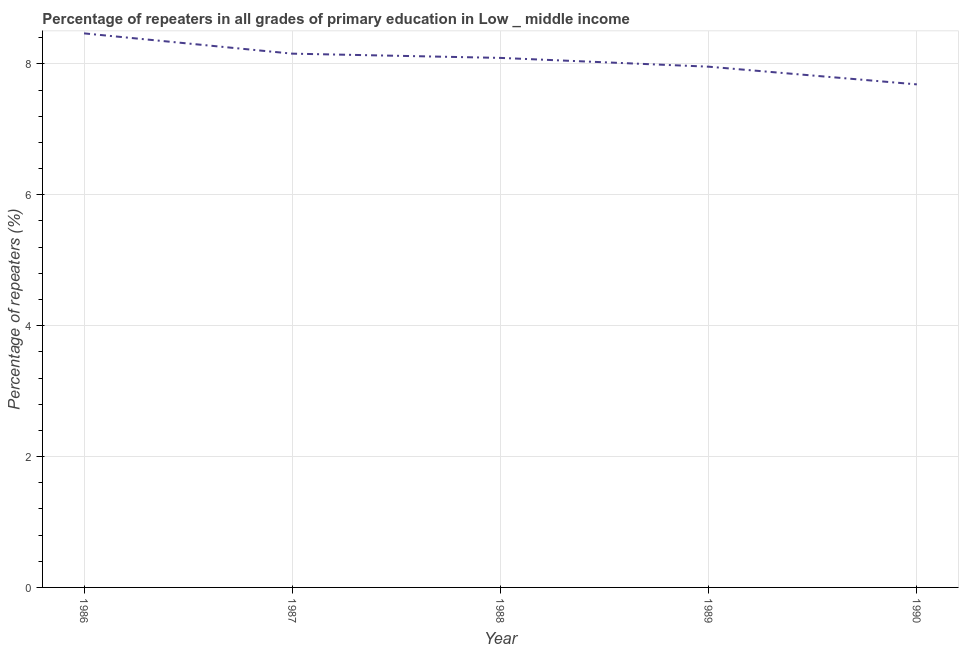What is the percentage of repeaters in primary education in 1988?
Ensure brevity in your answer.  8.09. Across all years, what is the maximum percentage of repeaters in primary education?
Offer a terse response. 8.47. Across all years, what is the minimum percentage of repeaters in primary education?
Keep it short and to the point. 7.69. In which year was the percentage of repeaters in primary education maximum?
Give a very brief answer. 1986. In which year was the percentage of repeaters in primary education minimum?
Make the answer very short. 1990. What is the sum of the percentage of repeaters in primary education?
Give a very brief answer. 40.36. What is the difference between the percentage of repeaters in primary education in 1986 and 1988?
Ensure brevity in your answer.  0.37. What is the average percentage of repeaters in primary education per year?
Offer a terse response. 8.07. What is the median percentage of repeaters in primary education?
Keep it short and to the point. 8.09. In how many years, is the percentage of repeaters in primary education greater than 6 %?
Offer a terse response. 5. What is the ratio of the percentage of repeaters in primary education in 1987 to that in 1990?
Give a very brief answer. 1.06. Is the percentage of repeaters in primary education in 1986 less than that in 1990?
Give a very brief answer. No. Is the difference between the percentage of repeaters in primary education in 1988 and 1990 greater than the difference between any two years?
Your answer should be very brief. No. What is the difference between the highest and the second highest percentage of repeaters in primary education?
Give a very brief answer. 0.31. What is the difference between the highest and the lowest percentage of repeaters in primary education?
Your response must be concise. 0.78. Does the percentage of repeaters in primary education monotonically increase over the years?
Provide a succinct answer. No. Are the values on the major ticks of Y-axis written in scientific E-notation?
Offer a terse response. No. Does the graph contain any zero values?
Make the answer very short. No. Does the graph contain grids?
Your answer should be compact. Yes. What is the title of the graph?
Offer a terse response. Percentage of repeaters in all grades of primary education in Low _ middle income. What is the label or title of the X-axis?
Your answer should be compact. Year. What is the label or title of the Y-axis?
Provide a succinct answer. Percentage of repeaters (%). What is the Percentage of repeaters (%) in 1986?
Provide a succinct answer. 8.47. What is the Percentage of repeaters (%) in 1987?
Keep it short and to the point. 8.16. What is the Percentage of repeaters (%) in 1988?
Ensure brevity in your answer.  8.09. What is the Percentage of repeaters (%) in 1989?
Keep it short and to the point. 7.96. What is the Percentage of repeaters (%) in 1990?
Your answer should be very brief. 7.69. What is the difference between the Percentage of repeaters (%) in 1986 and 1987?
Keep it short and to the point. 0.31. What is the difference between the Percentage of repeaters (%) in 1986 and 1988?
Offer a terse response. 0.37. What is the difference between the Percentage of repeaters (%) in 1986 and 1989?
Your answer should be compact. 0.51. What is the difference between the Percentage of repeaters (%) in 1986 and 1990?
Offer a terse response. 0.78. What is the difference between the Percentage of repeaters (%) in 1987 and 1988?
Give a very brief answer. 0.06. What is the difference between the Percentage of repeaters (%) in 1987 and 1989?
Provide a short and direct response. 0.2. What is the difference between the Percentage of repeaters (%) in 1987 and 1990?
Make the answer very short. 0.47. What is the difference between the Percentage of repeaters (%) in 1988 and 1989?
Your answer should be compact. 0.13. What is the difference between the Percentage of repeaters (%) in 1988 and 1990?
Provide a short and direct response. 0.4. What is the difference between the Percentage of repeaters (%) in 1989 and 1990?
Your answer should be compact. 0.27. What is the ratio of the Percentage of repeaters (%) in 1986 to that in 1987?
Offer a very short reply. 1.04. What is the ratio of the Percentage of repeaters (%) in 1986 to that in 1988?
Your response must be concise. 1.05. What is the ratio of the Percentage of repeaters (%) in 1986 to that in 1989?
Offer a very short reply. 1.06. What is the ratio of the Percentage of repeaters (%) in 1986 to that in 1990?
Keep it short and to the point. 1.1. What is the ratio of the Percentage of repeaters (%) in 1987 to that in 1990?
Your answer should be compact. 1.06. What is the ratio of the Percentage of repeaters (%) in 1988 to that in 1989?
Offer a very short reply. 1.02. What is the ratio of the Percentage of repeaters (%) in 1988 to that in 1990?
Offer a terse response. 1.05. What is the ratio of the Percentage of repeaters (%) in 1989 to that in 1990?
Your response must be concise. 1.03. 